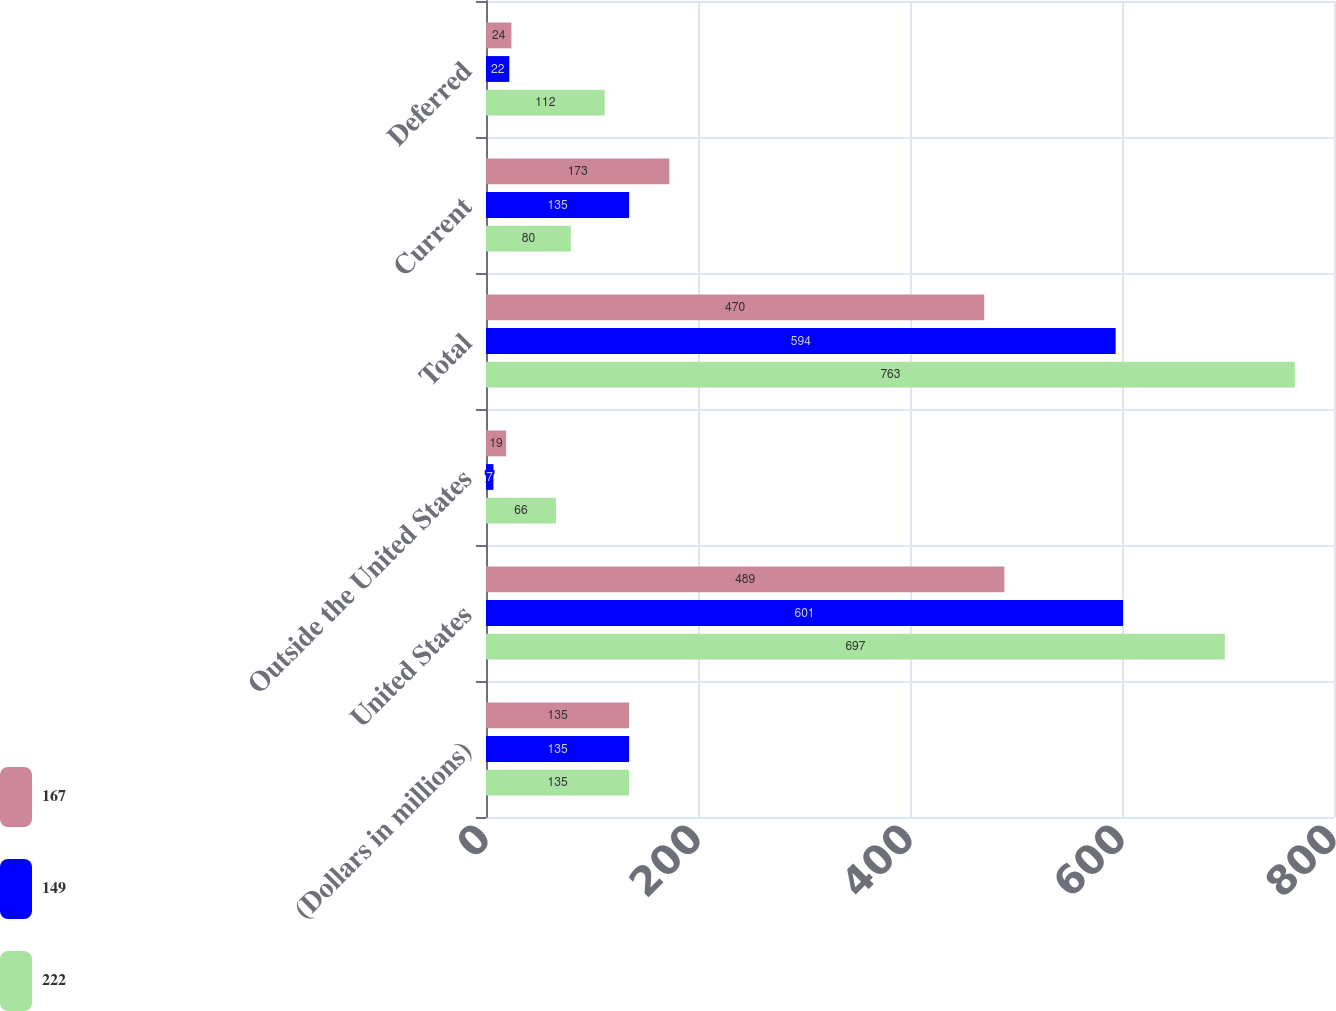<chart> <loc_0><loc_0><loc_500><loc_500><stacked_bar_chart><ecel><fcel>(Dollars in millions)<fcel>United States<fcel>Outside the United States<fcel>Total<fcel>Current<fcel>Deferred<nl><fcel>167<fcel>135<fcel>489<fcel>19<fcel>470<fcel>173<fcel>24<nl><fcel>149<fcel>135<fcel>601<fcel>7<fcel>594<fcel>135<fcel>22<nl><fcel>222<fcel>135<fcel>697<fcel>66<fcel>763<fcel>80<fcel>112<nl></chart> 